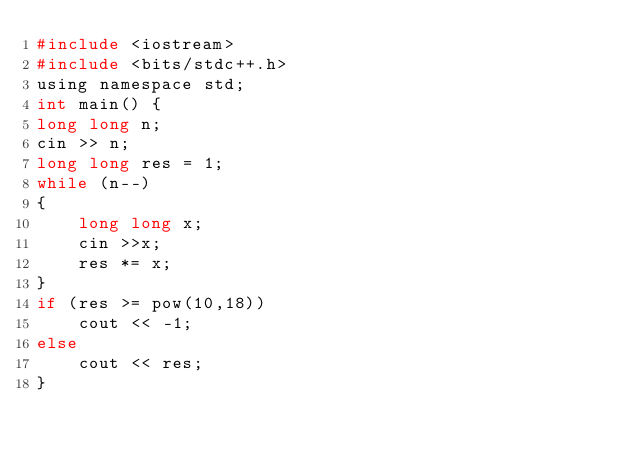<code> <loc_0><loc_0><loc_500><loc_500><_C_>#include <iostream>
#include <bits/stdc++.h>
using namespace std;
int main() {
long long n;
cin >> n;
long long res = 1;
while (n--)
{
    long long x;
    cin >>x;
    res *= x;
}
if (res >= pow(10,18))
    cout << -1;
else
    cout << res;
}
</code> 